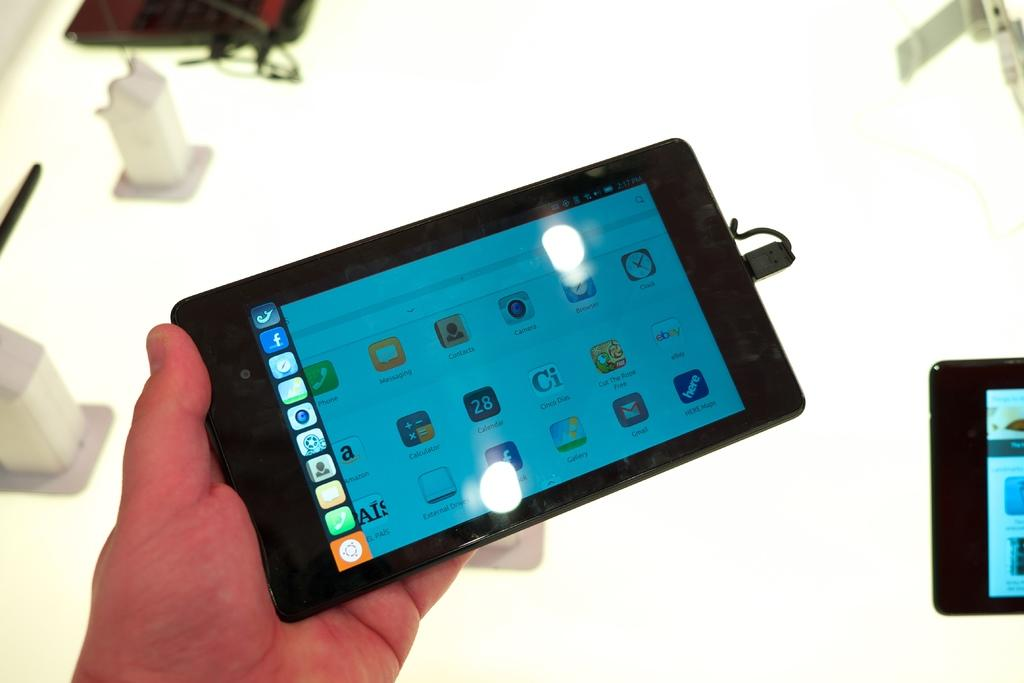What electronic device is visible in the image? There is a tablet in the image. Who is holding the tablet? A person is holding the tablet. What piece of furniture is present in the image? There is a table in the image. What else can be seen on the table besides the tablet? There are many gadgets on the table. How many centimeters of sugar are visible on the table in the image? There is no sugar present in the image, so it is not possible to determine the number of centimeters. Can you spot any lizards crawling on the gadgets in the image? There are no lizards present in the image; it only features a person holding a tablet and gadgets on a table. 